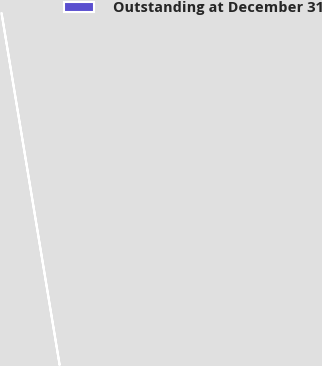Convert chart. <chart><loc_0><loc_0><loc_500><loc_500><pie_chart><fcel>Outstanding at December 31<nl><fcel>100.0%<nl></chart> 